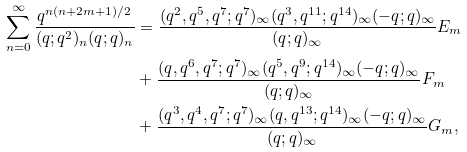<formula> <loc_0><loc_0><loc_500><loc_500>\sum _ { n = 0 } ^ { \infty } \frac { q ^ { n ( n + 2 m + 1 ) / 2 } } { ( q ; q ^ { 2 } ) _ { n } ( q ; q ) _ { n } } & = \frac { ( q ^ { 2 } , q ^ { 5 } , q ^ { 7 } ; q ^ { 7 } ) _ { \infty } ( q ^ { 3 } , q ^ { 1 1 } ; q ^ { 1 4 } ) _ { \infty } ( - q ; q ) _ { \infty } } { ( q ; q ) _ { \infty } } E _ { m } \\ & + \frac { ( q , q ^ { 6 } , q ^ { 7 } ; q ^ { 7 } ) _ { \infty } ( q ^ { 5 } , q ^ { 9 } ; q ^ { 1 4 } ) _ { \infty } ( - q ; q ) _ { \infty } } { ( q ; q ) _ { \infty } } F _ { m } \\ & + \frac { ( q ^ { 3 } , q ^ { 4 } , q ^ { 7 } ; q ^ { 7 } ) _ { \infty } ( q , q ^ { 1 3 } ; q ^ { 1 4 } ) _ { \infty } ( - q ; q ) _ { \infty } } { ( q ; q ) _ { \infty } } G _ { m } ,</formula> 